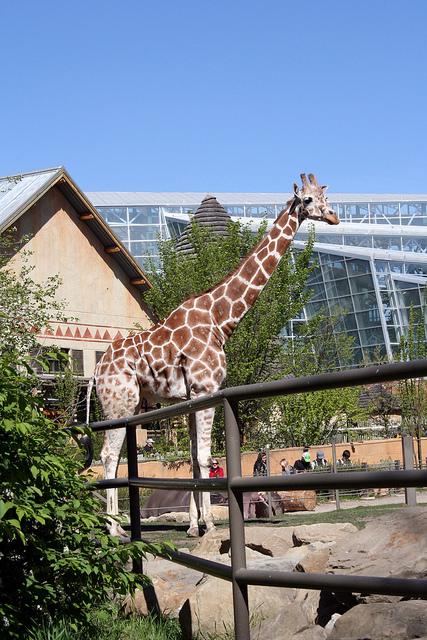What animal is this?
Keep it brief. Giraffe. Where does this giraffe live?
Concise answer only. Zoo. Can any people be seen?
Answer briefly. Yes. 